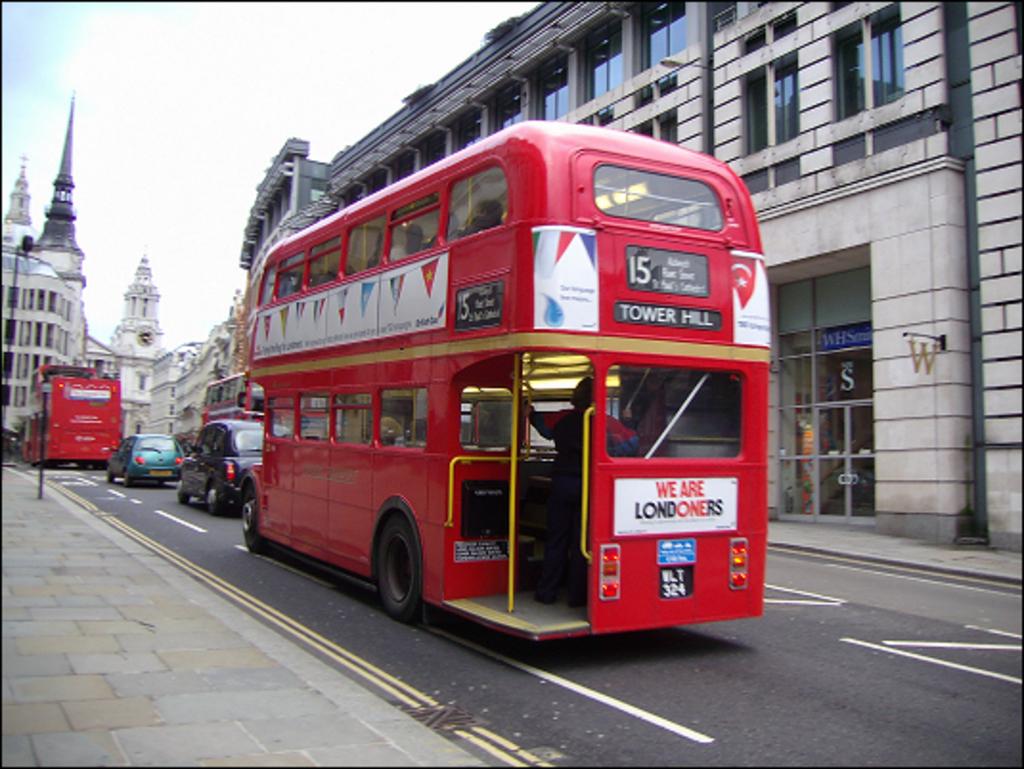Where is this bus headed?
Your response must be concise. Tower hill. Bus tower hill?
Your answer should be compact. Yes. 